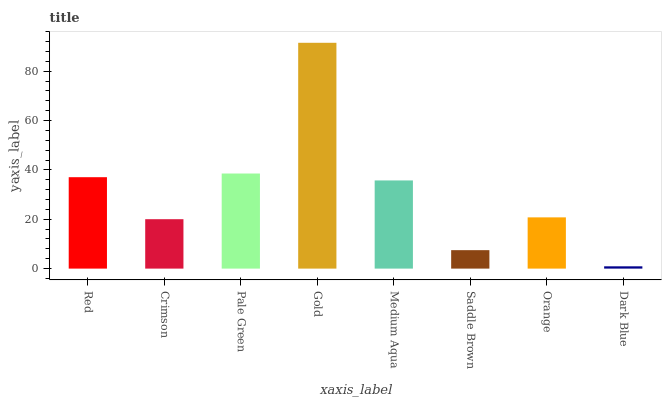Is Crimson the minimum?
Answer yes or no. No. Is Crimson the maximum?
Answer yes or no. No. Is Red greater than Crimson?
Answer yes or no. Yes. Is Crimson less than Red?
Answer yes or no. Yes. Is Crimson greater than Red?
Answer yes or no. No. Is Red less than Crimson?
Answer yes or no. No. Is Medium Aqua the high median?
Answer yes or no. Yes. Is Orange the low median?
Answer yes or no. Yes. Is Crimson the high median?
Answer yes or no. No. Is Medium Aqua the low median?
Answer yes or no. No. 